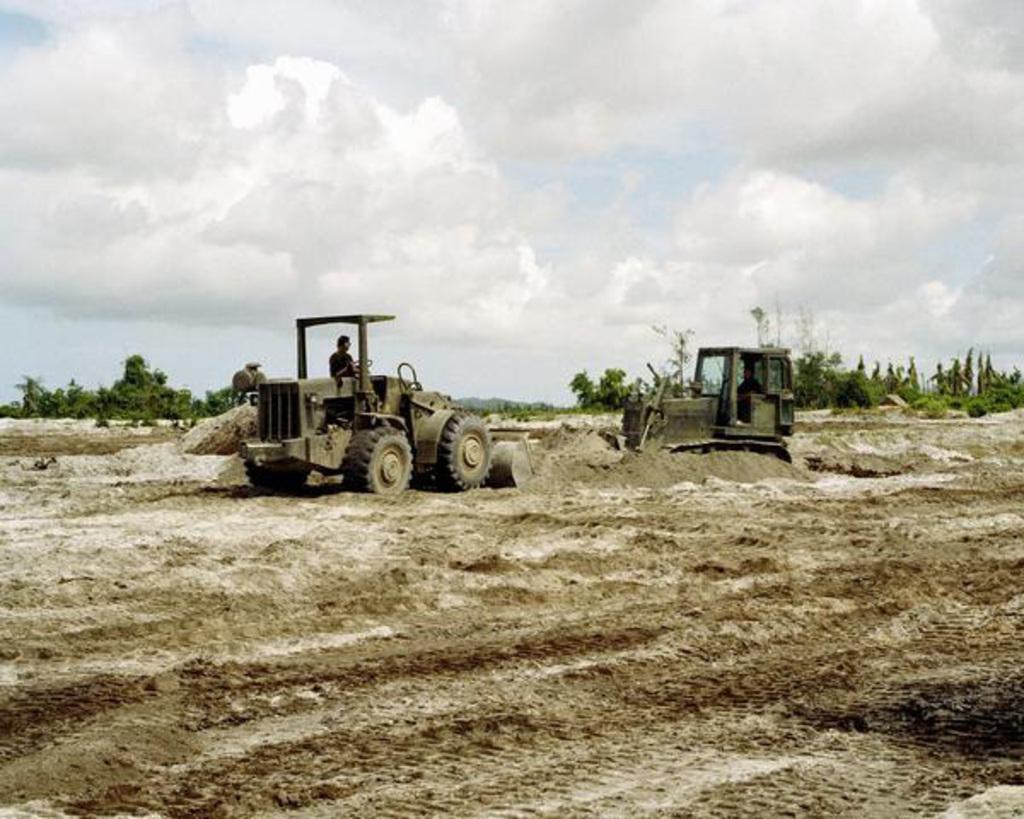In one or two sentences, can you explain what this image depicts? There are two people sitting and riding vehicles. In the background we can see trees and sky with clouds. 